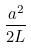<formula> <loc_0><loc_0><loc_500><loc_500>\frac { a ^ { 2 } } { 2 L }</formula> 